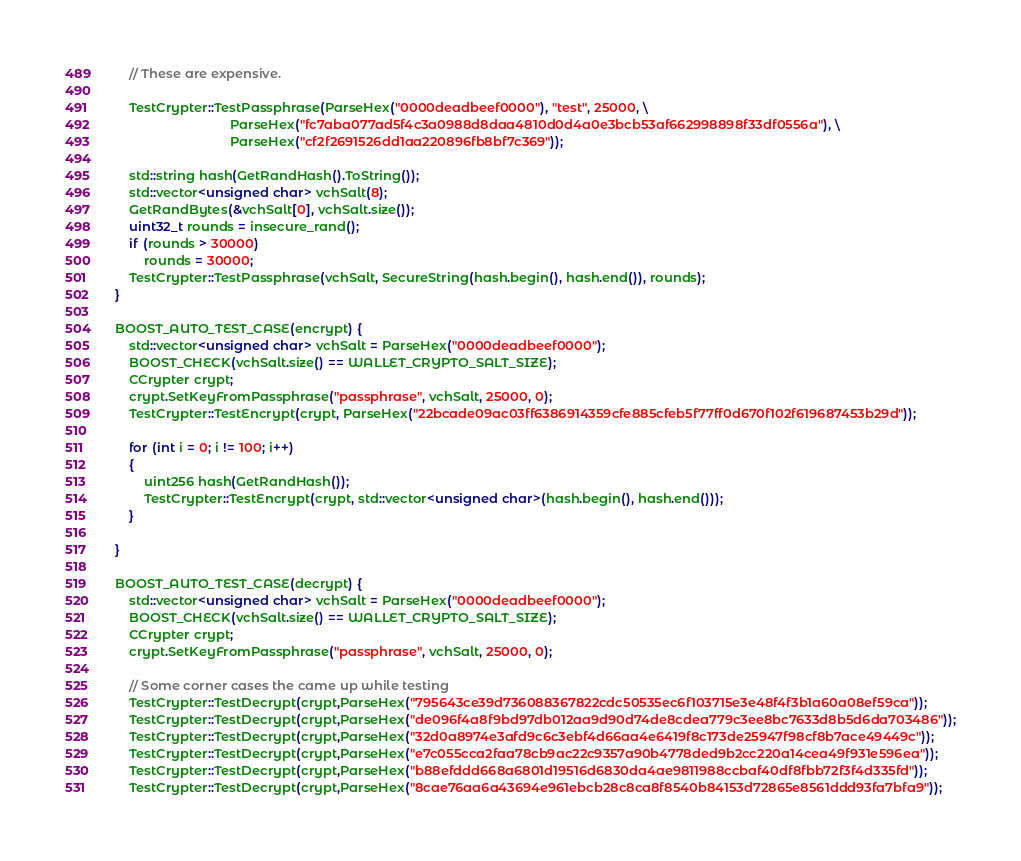Convert code to text. <code><loc_0><loc_0><loc_500><loc_500><_C++_>    // These are expensive.

    TestCrypter::TestPassphrase(ParseHex("0000deadbeef0000"), "test", 25000, \
                                ParseHex("fc7aba077ad5f4c3a0988d8daa4810d0d4a0e3bcb53af662998898f33df0556a"), \
                                ParseHex("cf2f2691526dd1aa220896fb8bf7c369"));

    std::string hash(GetRandHash().ToString());
    std::vector<unsigned char> vchSalt(8);
    GetRandBytes(&vchSalt[0], vchSalt.size());
    uint32_t rounds = insecure_rand();
    if (rounds > 30000)
        rounds = 30000;
    TestCrypter::TestPassphrase(vchSalt, SecureString(hash.begin(), hash.end()), rounds);
}

BOOST_AUTO_TEST_CASE(encrypt) {
    std::vector<unsigned char> vchSalt = ParseHex("0000deadbeef0000");
    BOOST_CHECK(vchSalt.size() == WALLET_CRYPTO_SALT_SIZE);
    CCrypter crypt;
    crypt.SetKeyFromPassphrase("passphrase", vchSalt, 25000, 0);
    TestCrypter::TestEncrypt(crypt, ParseHex("22bcade09ac03ff6386914359cfe885cfeb5f77ff0d670f102f619687453b29d"));

    for (int i = 0; i != 100; i++)
    {
        uint256 hash(GetRandHash());
        TestCrypter::TestEncrypt(crypt, std::vector<unsigned char>(hash.begin(), hash.end()));
    }

}

BOOST_AUTO_TEST_CASE(decrypt) {
    std::vector<unsigned char> vchSalt = ParseHex("0000deadbeef0000");
    BOOST_CHECK(vchSalt.size() == WALLET_CRYPTO_SALT_SIZE);
    CCrypter crypt;
    crypt.SetKeyFromPassphrase("passphrase", vchSalt, 25000, 0);

    // Some corner cases the came up while testing
    TestCrypter::TestDecrypt(crypt,ParseHex("795643ce39d736088367822cdc50535ec6f103715e3e48f4f3b1a60a08ef59ca"));
    TestCrypter::TestDecrypt(crypt,ParseHex("de096f4a8f9bd97db012aa9d90d74de8cdea779c3ee8bc7633d8b5d6da703486"));
    TestCrypter::TestDecrypt(crypt,ParseHex("32d0a8974e3afd9c6c3ebf4d66aa4e6419f8c173de25947f98cf8b7ace49449c"));
    TestCrypter::TestDecrypt(crypt,ParseHex("e7c055cca2faa78cb9ac22c9357a90b4778ded9b2cc220a14cea49f931e596ea"));
    TestCrypter::TestDecrypt(crypt,ParseHex("b88efddd668a6801d19516d6830da4ae9811988ccbaf40df8fbb72f3f4d335fd"));
    TestCrypter::TestDecrypt(crypt,ParseHex("8cae76aa6a43694e961ebcb28c8ca8f8540b84153d72865e8561ddd93fa7bfa9"));
</code> 